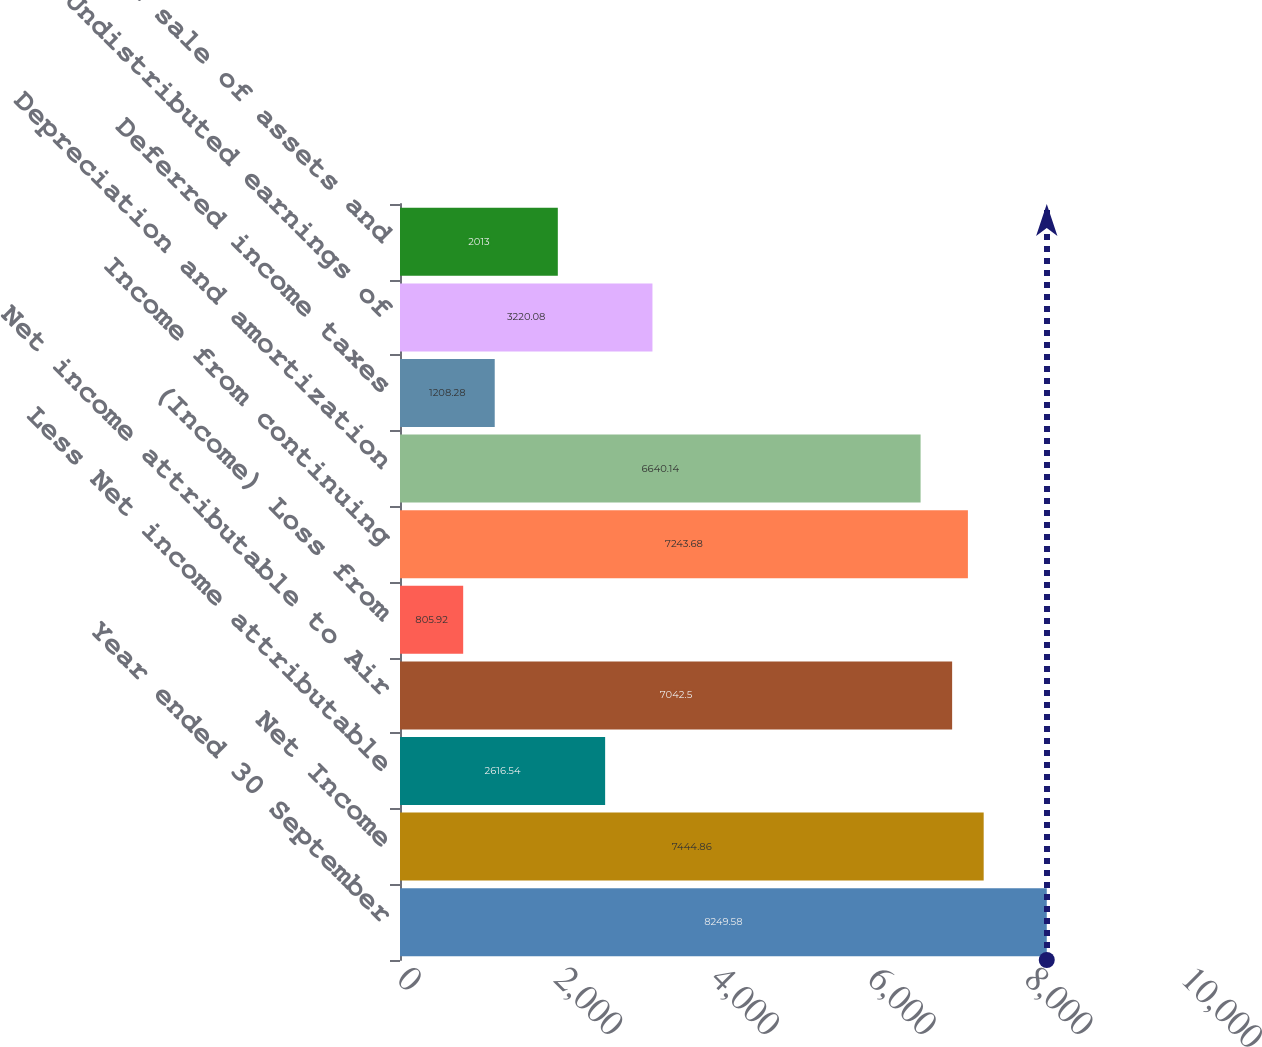<chart> <loc_0><loc_0><loc_500><loc_500><bar_chart><fcel>Year ended 30 September<fcel>Net Income<fcel>Less Net income attributable<fcel>Net income attributable to Air<fcel>(Income) Loss from<fcel>Income from continuing<fcel>Depreciation and amortization<fcel>Deferred income taxes<fcel>Undistributed earnings of<fcel>Gain on sale of assets and<nl><fcel>8249.58<fcel>7444.86<fcel>2616.54<fcel>7042.5<fcel>805.92<fcel>7243.68<fcel>6640.14<fcel>1208.28<fcel>3220.08<fcel>2013<nl></chart> 